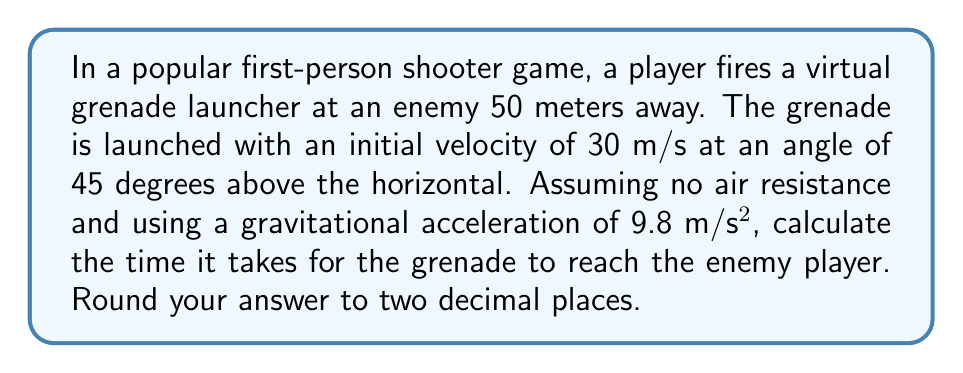Can you solve this math problem? Let's approach this step-by-step using the principles of projectile motion:

1) In projectile motion, we can treat the horizontal and vertical components separately.

2) The horizontal distance is 50 meters. We need to find the time it takes to cover this distance.

3) The initial velocity components are:
   $v_x = v \cos \theta = 30 \cos 45° = 30 \cdot \frac{\sqrt{2}}{2} \approx 21.21$ m/s
   $v_y = v \sin \theta = 30 \sin 45° = 30 \cdot \frac{\sqrt{2}}{2} \approx 21.21$ m/s

4) Horizontal motion is uniform:
   $x = v_x t$
   $50 = 21.21t$
   $t = \frac{50}{21.21} \approx 2.36$ seconds

5) To verify, let's check the vertical motion:
   $y = v_y t - \frac{1}{2}gt^2$
   $y = 21.21 \cdot 2.36 - \frac{1}{2} \cdot 9.8 \cdot 2.36^2$
   $y \approx 50 - 27.2 = 22.8$ meters

6) This positive y-value confirms that the grenade is still above the ground when it reaches the enemy.

Therefore, it takes approximately 2.36 seconds for the grenade to reach the enemy player.
Answer: 2.36 seconds 